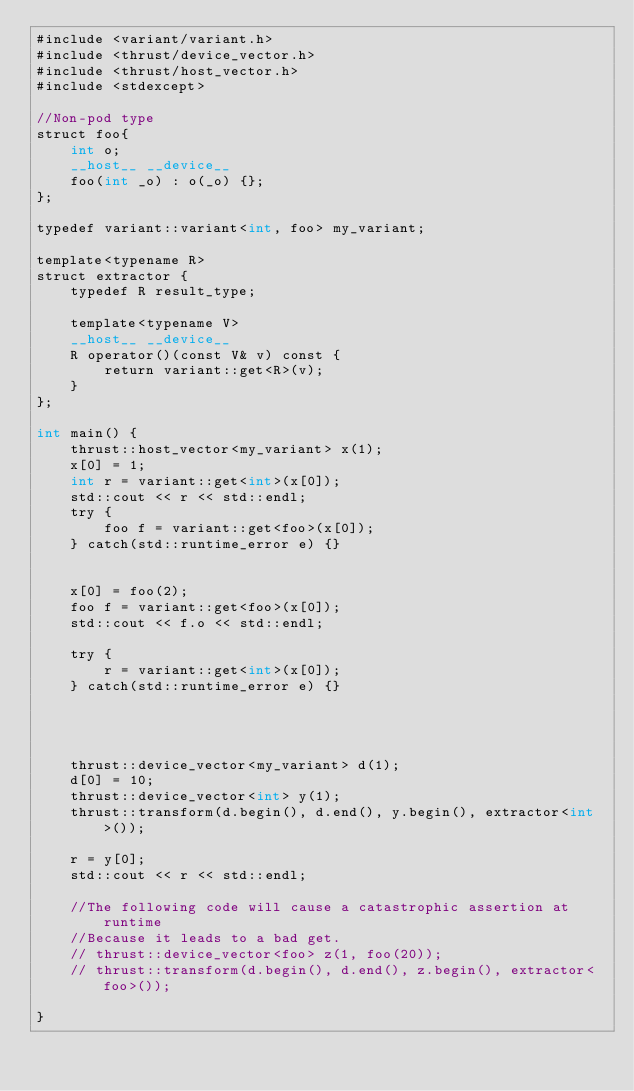Convert code to text. <code><loc_0><loc_0><loc_500><loc_500><_Cuda_>#include <variant/variant.h>
#include <thrust/device_vector.h>
#include <thrust/host_vector.h>
#include <stdexcept>

//Non-pod type
struct foo{
    int o;
    __host__ __device__
    foo(int _o) : o(_o) {};
};

typedef variant::variant<int, foo> my_variant;

template<typename R>
struct extractor {
    typedef R result_type;

    template<typename V>
    __host__ __device__
    R operator()(const V& v) const {
        return variant::get<R>(v);
    }
};

int main() {
    thrust::host_vector<my_variant> x(1);
    x[0] = 1;
    int r = variant::get<int>(x[0]);
    std::cout << r << std::endl;
    try {
        foo f = variant::get<foo>(x[0]);
    } catch(std::runtime_error e) {}


    x[0] = foo(2);
    foo f = variant::get<foo>(x[0]);
    std::cout << f.o << std::endl;

    try {
        r = variant::get<int>(x[0]);
    } catch(std::runtime_error e) {}


    

    thrust::device_vector<my_variant> d(1);
    d[0] = 10;
    thrust::device_vector<int> y(1);
    thrust::transform(d.begin(), d.end(), y.begin(), extractor<int>());

    r = y[0];
    std::cout << r << std::endl;

    //The following code will cause a catastrophic assertion at runtime
    //Because it leads to a bad get.
    // thrust::device_vector<foo> z(1, foo(20));
    // thrust::transform(d.begin(), d.end(), z.begin(), extractor<foo>());
    
}

</code> 